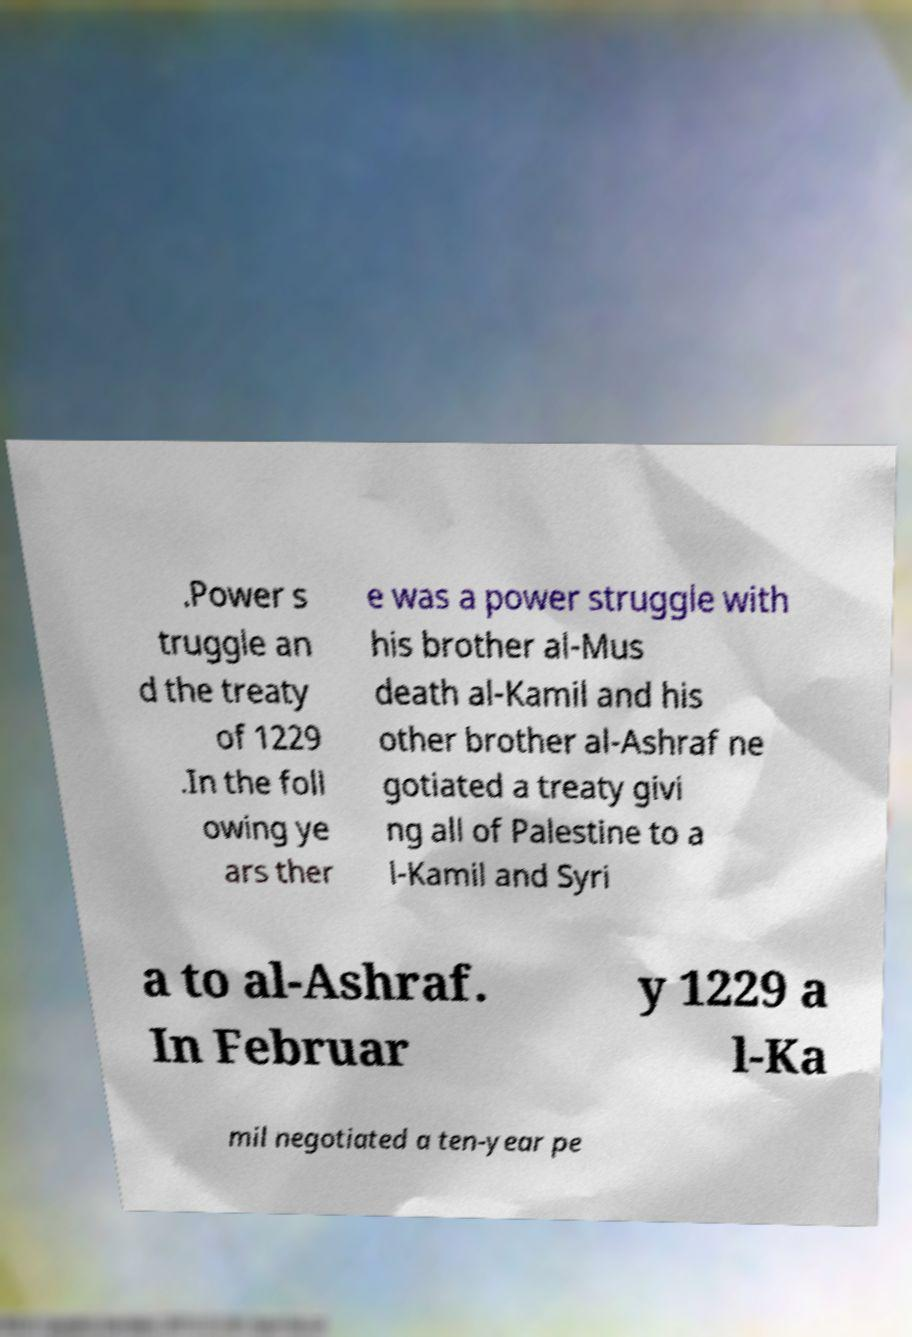Please read and relay the text visible in this image. What does it say? .Power s truggle an d the treaty of 1229 .In the foll owing ye ars ther e was a power struggle with his brother al-Mus death al-Kamil and his other brother al-Ashraf ne gotiated a treaty givi ng all of Palestine to a l-Kamil and Syri a to al-Ashraf. In Februar y 1229 a l-Ka mil negotiated a ten-year pe 